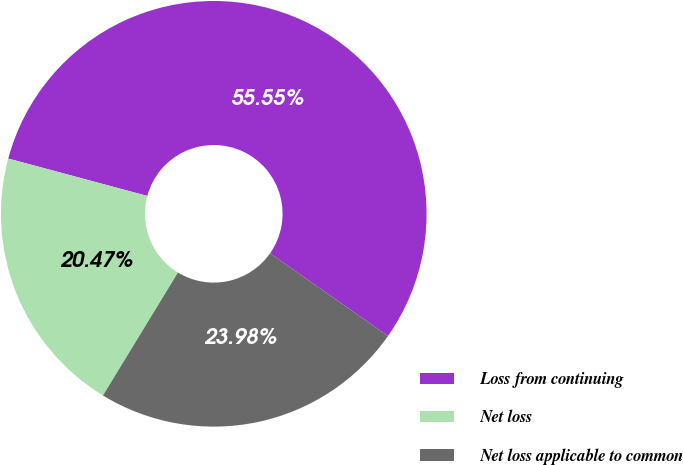Convert chart to OTSL. <chart><loc_0><loc_0><loc_500><loc_500><pie_chart><fcel>Loss from continuing<fcel>Net loss<fcel>Net loss applicable to common<nl><fcel>55.56%<fcel>20.47%<fcel>23.98%<nl></chart> 